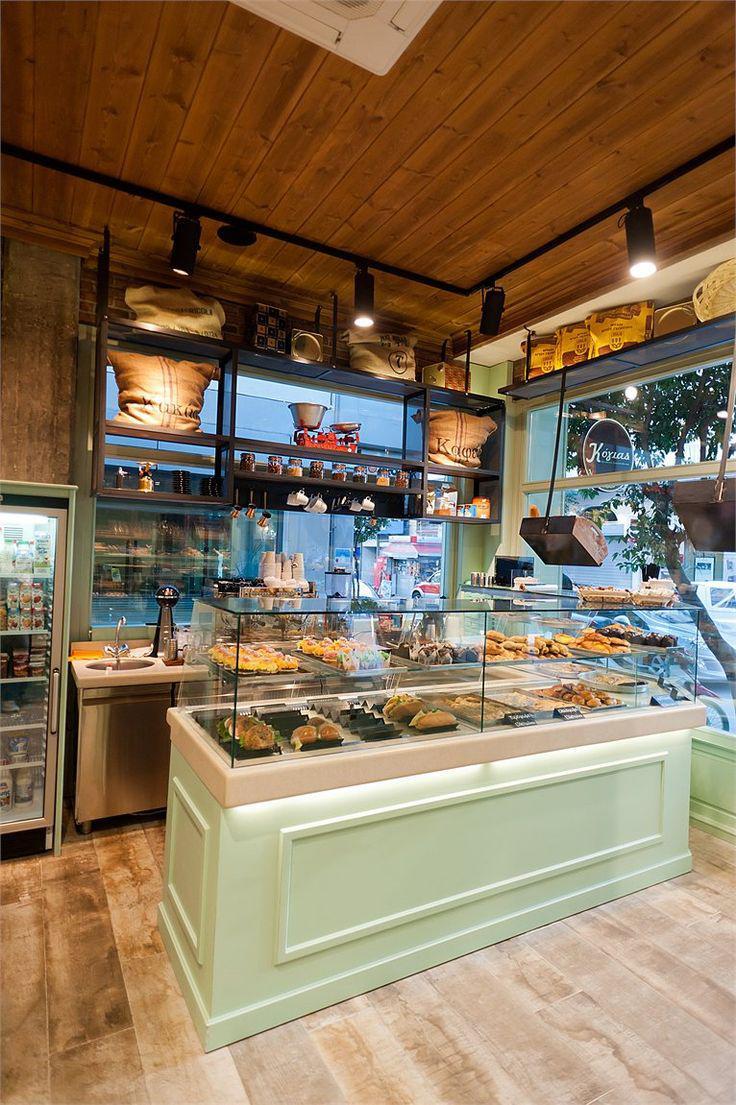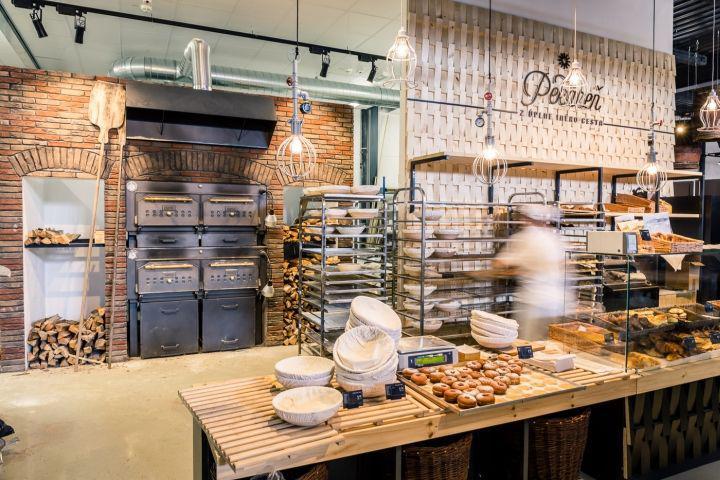The first image is the image on the left, the second image is the image on the right. For the images shown, is this caption "There are at least five haning lights in the image on the right." true? Answer yes or no. Yes. 